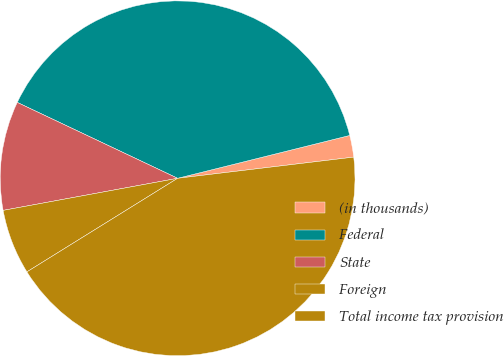<chart> <loc_0><loc_0><loc_500><loc_500><pie_chart><fcel>(in thousands)<fcel>Federal<fcel>State<fcel>Foreign<fcel>Total income tax provision<nl><fcel>1.98%<fcel>39.08%<fcel>9.93%<fcel>5.95%<fcel>43.06%<nl></chart> 